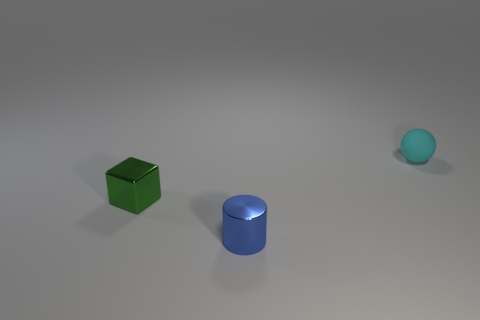Are there any other things that are made of the same material as the tiny cyan thing?
Your answer should be compact. No. Is the size of the object that is on the right side of the cylinder the same as the green object that is on the left side of the blue thing?
Make the answer very short. Yes. There is a small green shiny cube; are there any matte things in front of it?
Keep it short and to the point. No. There is a tiny metallic thing that is right of the small shiny object on the left side of the tiny cylinder; what is its color?
Give a very brief answer. Blue. Are there fewer spheres than tiny purple spheres?
Your answer should be very brief. No. What number of other rubber objects are the same shape as the cyan rubber object?
Provide a short and direct response. 0. There is a rubber sphere that is the same size as the blue cylinder; what color is it?
Keep it short and to the point. Cyan. Is the number of small shiny things in front of the tiny green cube the same as the number of cyan matte objects left of the small cylinder?
Your answer should be compact. No. Are there any cylinders of the same size as the cyan rubber thing?
Provide a short and direct response. Yes. How big is the blue metallic cylinder?
Your answer should be very brief. Small. 